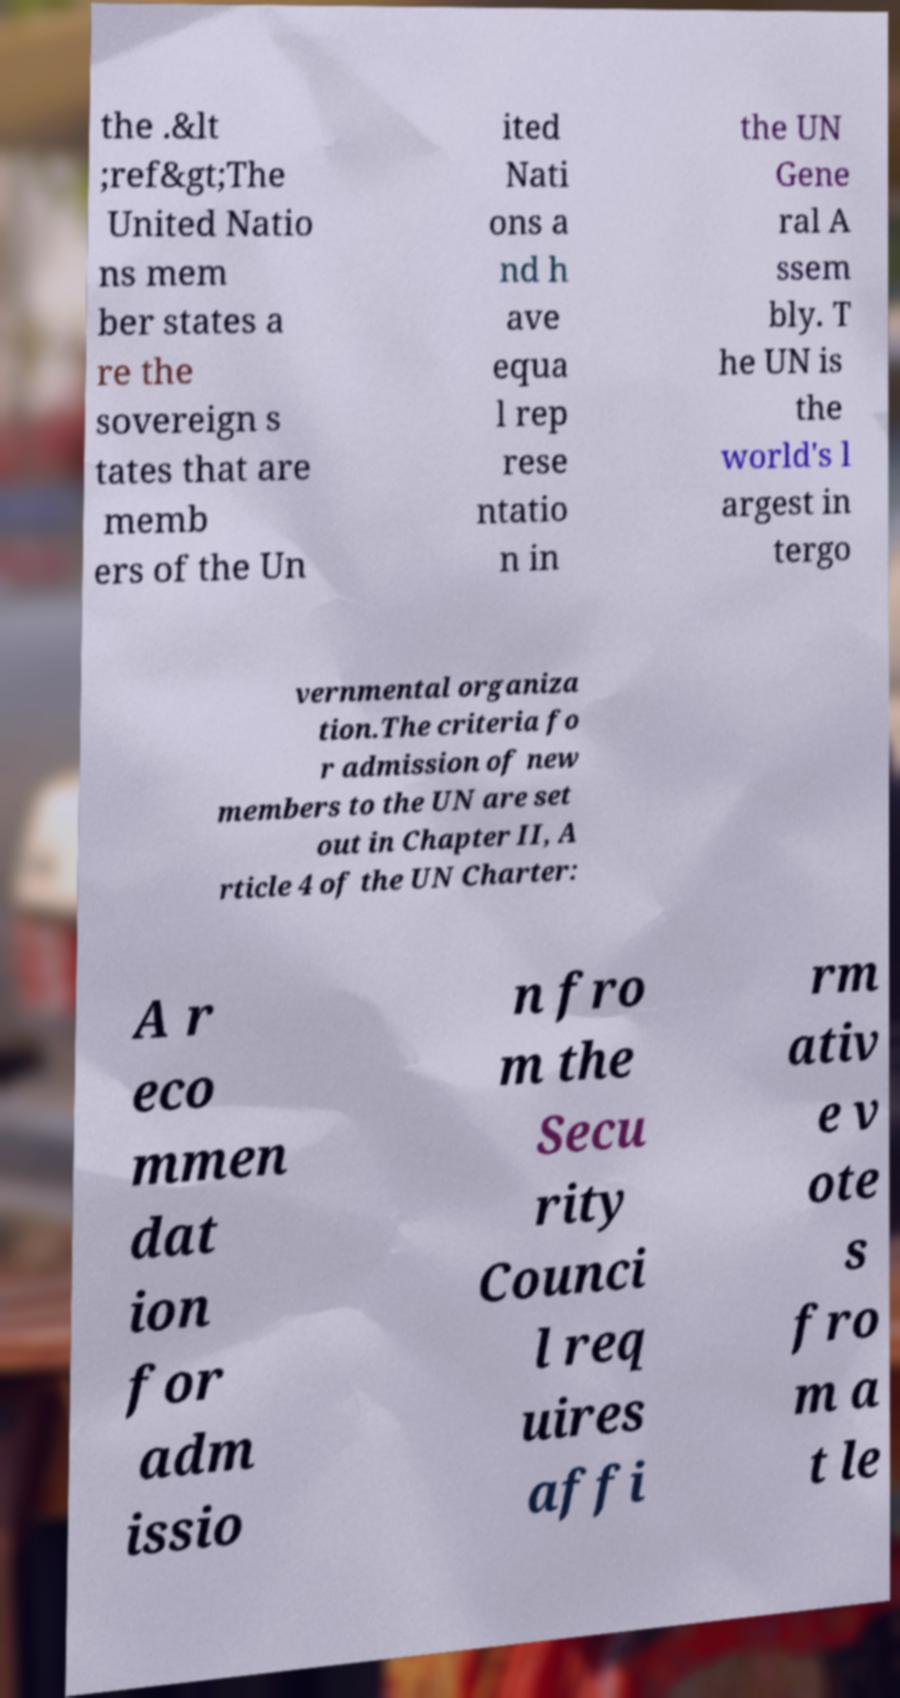I need the written content from this picture converted into text. Can you do that? the .&lt ;ref&gt;The United Natio ns mem ber states a re the sovereign s tates that are memb ers of the Un ited Nati ons a nd h ave equa l rep rese ntatio n in the UN Gene ral A ssem bly. T he UN is the world's l argest in tergo vernmental organiza tion.The criteria fo r admission of new members to the UN are set out in Chapter II, A rticle 4 of the UN Charter: A r eco mmen dat ion for adm issio n fro m the Secu rity Counci l req uires affi rm ativ e v ote s fro m a t le 